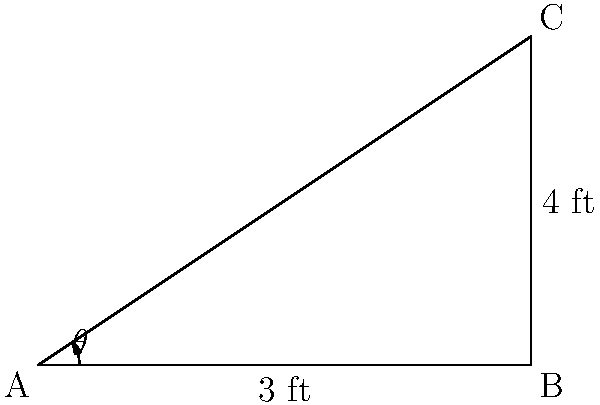During a resistance band workout, you anchor one end of the band to the floor (point A) and hold the other end at chest height (point C). The band forms a right triangle with the floor, where the distance from the anchor to directly below your hand (AB) is 3 feet, and the height from the floor to your hand (BC) is 4 feet. If the angle between the floor and the stretched band ($\theta$) is approximately 33.69°, what is the length of the stretched resistance band (AC) to the nearest tenth of a foot? Let's solve this step-by-step using the Pythagorean theorem:

1) We have a right triangle ABC, where:
   AB = 3 feet (base)
   BC = 4 feet (height)
   AC = unknown (hypotenuse)

2) The Pythagorean theorem states: $a^2 + b^2 = c^2$
   Where c is the hypotenuse and a and b are the other two sides.

3) Substituting our known values:
   $3^2 + 4^2 = AC^2$

4) Simplify:
   $9 + 16 = AC^2$
   $25 = AC^2$

5) Take the square root of both sides:
   $\sqrt{25} = AC$
   $5 = AC$

6) Therefore, the length of the stretched resistance band (AC) is 5 feet.

Note: The angle $\theta$ wasn't needed for this calculation, but it's approximately $\arctan(\frac{4}{3}) \approx 33.69°$, which matches the given information.
Answer: 5.0 feet 